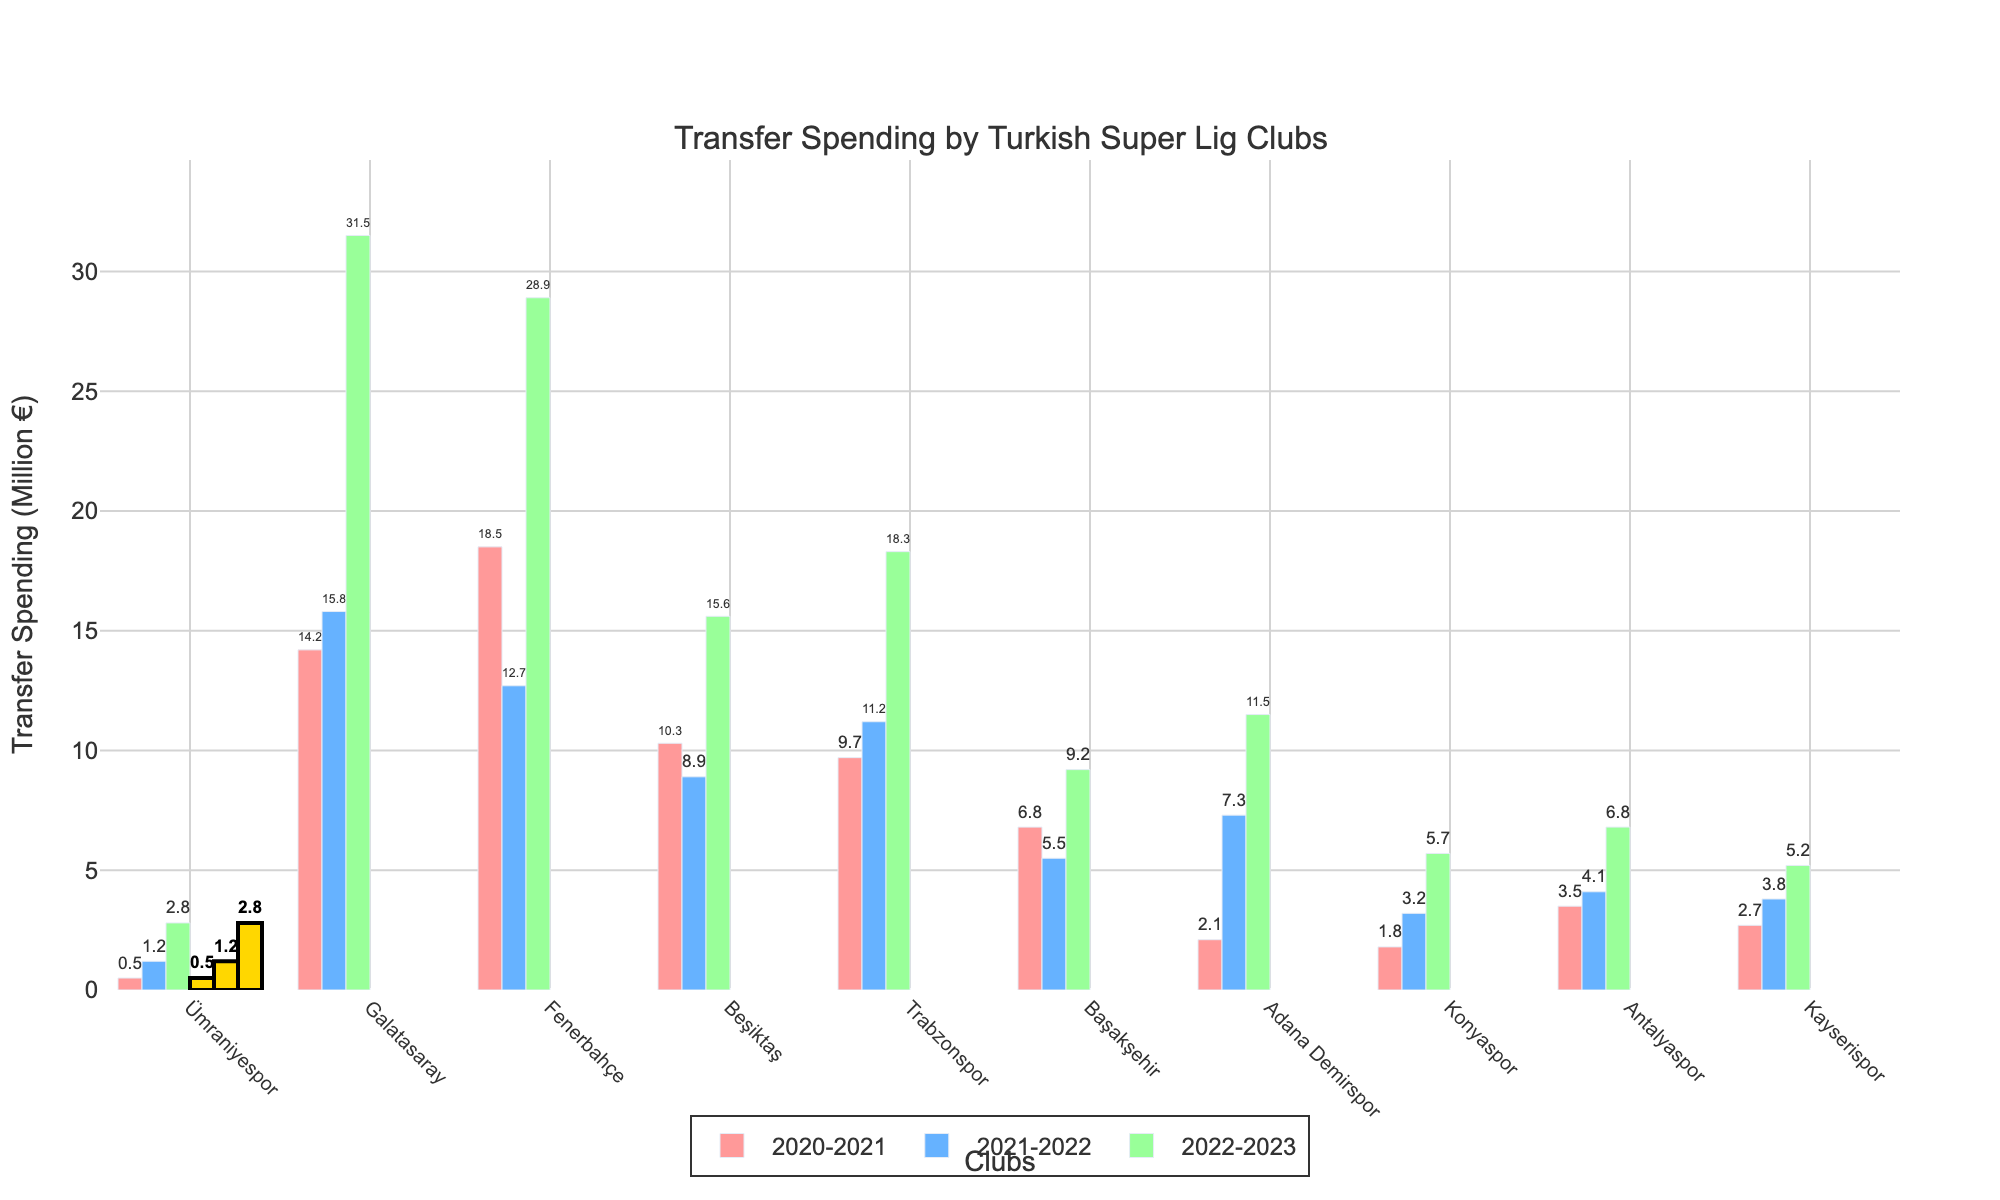Which club had the highest transfer spending in the 2022-2023 season? Observing the height of the bars for the 2022-2023 season, Galatasaray has the tallest bar, indicating the highest transfer spending.
Answer: Galatasaray How much did Ümraniyespor increase its transfer spending from the 2021-2022 season to the 2022-2023 season? In 2021-2022, Ümraniyespor's transfer spending was 1.2 million euros, and it increased to 2.8 million euros in 2022-2023. The increase is 2.8 - 1.2 = 1.6 million euros.
Answer: 1.6 million euros Which club spent less than Ümraniyespor in the 2022-2023 season? In the 2022-2023 season, all other clubs have bars higher than Ümraniyespor, indicating no club spent less than Ümraniyespor.
Answer: None What is the total transfer spending of Trabzonspor over the three seasons? Adding Trabzonspor's spending for each season: 9.7 (2020-2021) + 11.2 (2021-2022) + 18.3 (2022-2023) = 39.2 million euros.
Answer: 39.2 million euros Compare the transfer spending of Ümraniyespor and Konyaspor in the 2021-2022 season. The height of Konyaspor's bar in 2021-2022 is 3.2 million euros, which is greater than Ümraniyespor's 1.2 million euros.
Answer: Konyaspor spent more Which season saw the highest transfer spending for Fenerbahçe? The tallest bar for Fenerbahçe belongs to the 2020-2021 season, with 18.5 million euros.
Answer: 2020-2021 What is the combined transfer spending of Antalyaspor and Kayserispor in the 2020-2021 season? Summing up their transfer spending: Antalyaspor (3.5 million) + Kayserispor (2.7 million) = 6.2 million euros.
Answer: 6.2 million euros Which club has the highest cumulative transfer spending over all three seasons? Summing the values for each club, Galatasaray has the highest cumulative spending: 14.2 + 15.8 + 31.5 = 61.5 million euros.
Answer: Galatasaray 